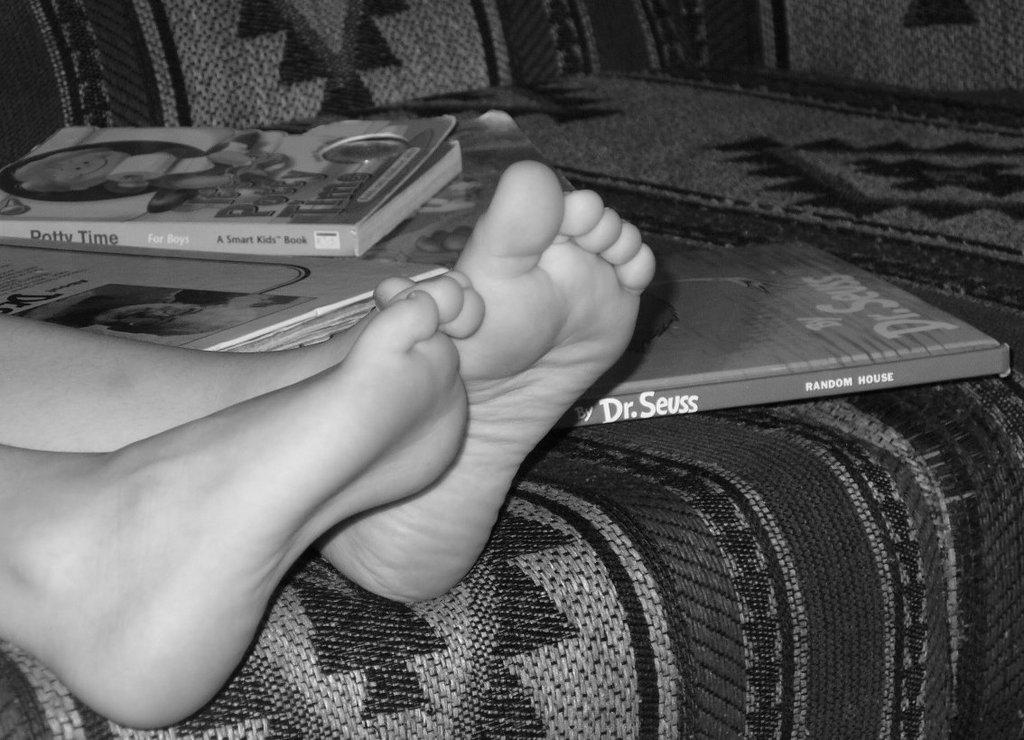What is visible at the front of the image? There are legs of a person in the front of the image. What can be seen in the center of the image? There are books on a couch in the center of the image. What is depicted on the books? The books have text and images on them. What type of celery can be seen growing on the couch in the image? There is no celery present in the image; it features books on a couch. How many bears are visible on the books in the image? There are no bears depicted on the books in the image; they have text and images on them, but no bears. 